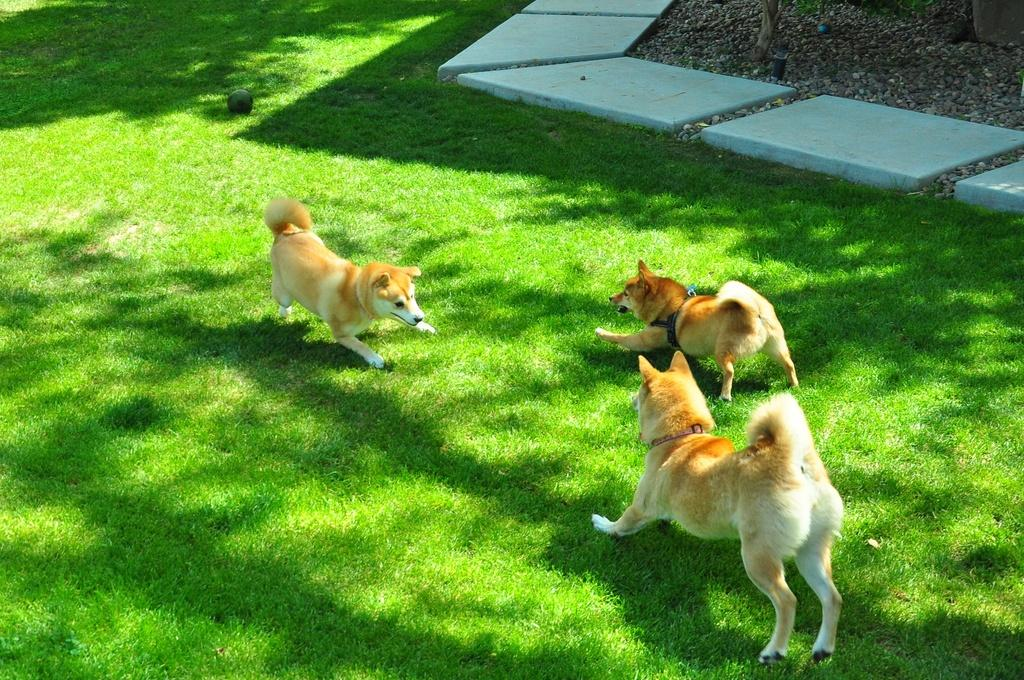How many dogs are in the image? There are three dogs in the image. Where are the dogs located? The dogs are on the grass. What objects can be seen in addition to the dogs? There are marbles and stones visible in the image. What type of wool is being used by the men in the image? There are no men or wool present in the image; it features three dogs on the grass with marbles and stones. 